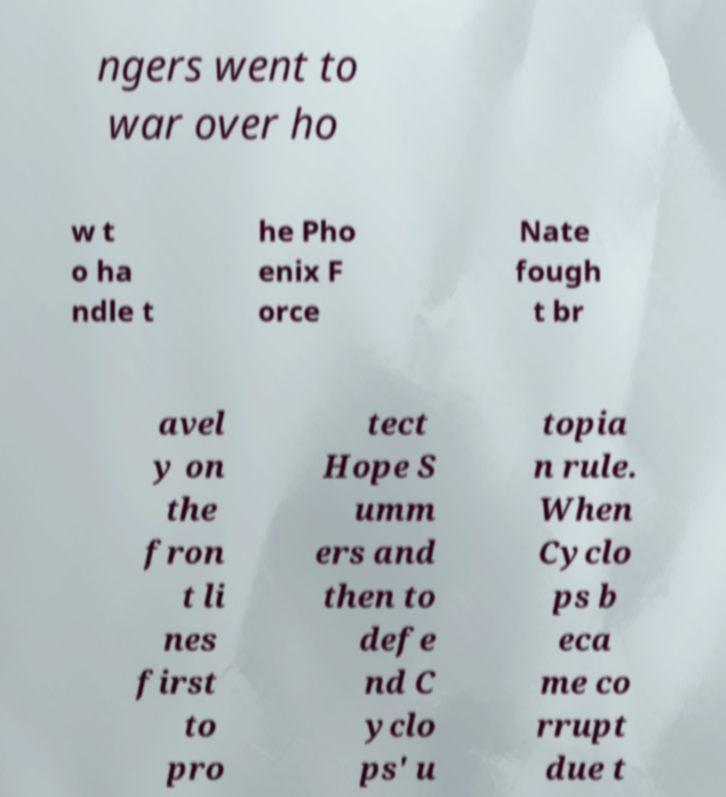Please read and relay the text visible in this image. What does it say? ngers went to war over ho w t o ha ndle t he Pho enix F orce Nate fough t br avel y on the fron t li nes first to pro tect Hope S umm ers and then to defe nd C yclo ps' u topia n rule. When Cyclo ps b eca me co rrupt due t 